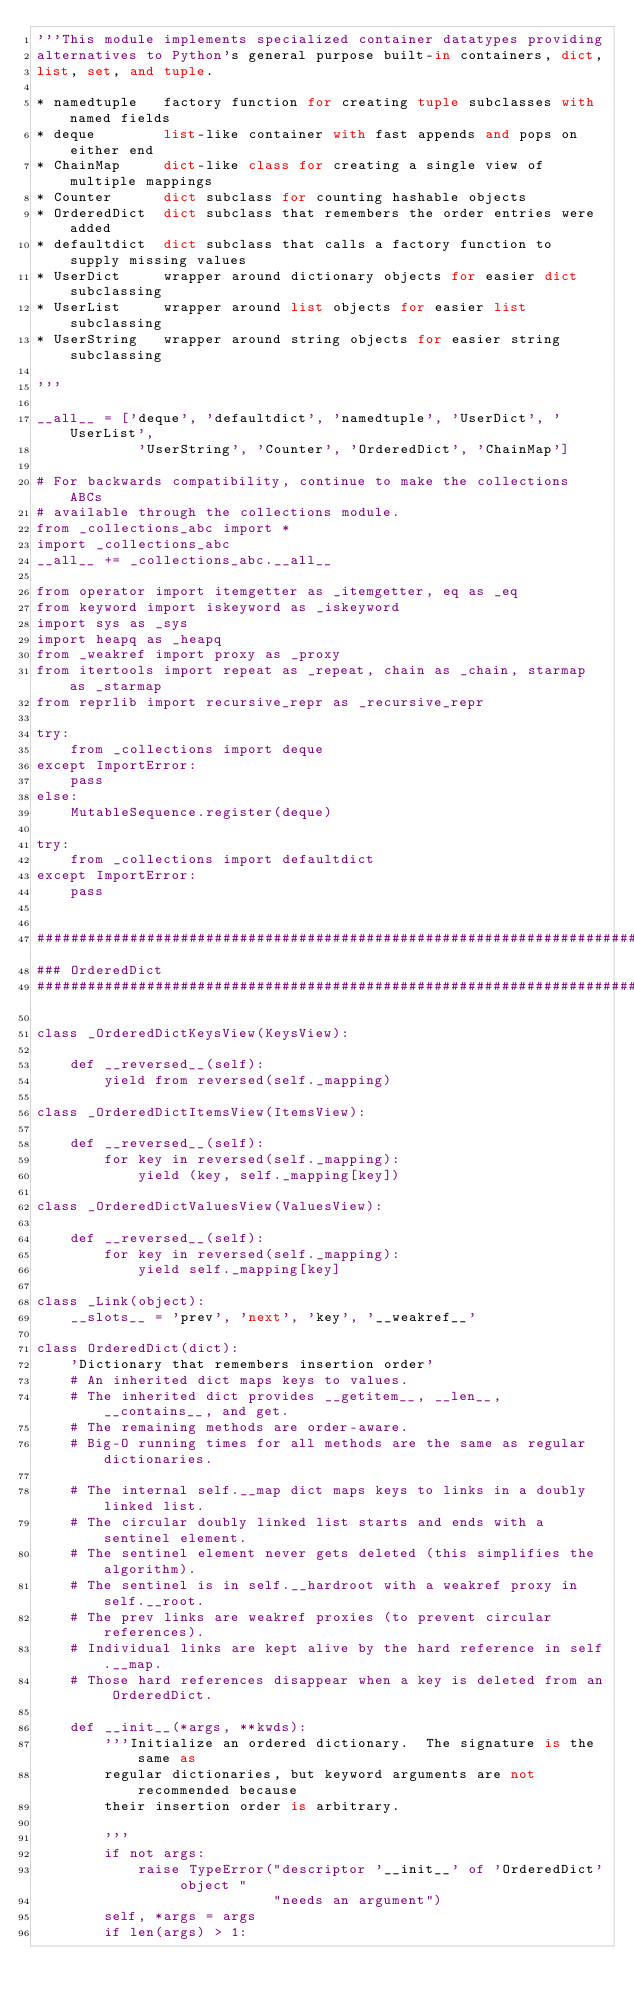<code> <loc_0><loc_0><loc_500><loc_500><_Python_>'''This module implements specialized container datatypes providing
alternatives to Python's general purpose built-in containers, dict,
list, set, and tuple.

* namedtuple   factory function for creating tuple subclasses with named fields
* deque        list-like container with fast appends and pops on either end
* ChainMap     dict-like class for creating a single view of multiple mappings
* Counter      dict subclass for counting hashable objects
* OrderedDict  dict subclass that remembers the order entries were added
* defaultdict  dict subclass that calls a factory function to supply missing values
* UserDict     wrapper around dictionary objects for easier dict subclassing
* UserList     wrapper around list objects for easier list subclassing
* UserString   wrapper around string objects for easier string subclassing

'''

__all__ = ['deque', 'defaultdict', 'namedtuple', 'UserDict', 'UserList',
            'UserString', 'Counter', 'OrderedDict', 'ChainMap']

# For backwards compatibility, continue to make the collections ABCs
# available through the collections module.
from _collections_abc import *
import _collections_abc
__all__ += _collections_abc.__all__

from operator import itemgetter as _itemgetter, eq as _eq
from keyword import iskeyword as _iskeyword
import sys as _sys
import heapq as _heapq
from _weakref import proxy as _proxy
from itertools import repeat as _repeat, chain as _chain, starmap as _starmap
from reprlib import recursive_repr as _recursive_repr

try:
    from _collections import deque
except ImportError:
    pass
else:
    MutableSequence.register(deque)

try:
    from _collections import defaultdict
except ImportError:
    pass


################################################################################
### OrderedDict
################################################################################

class _OrderedDictKeysView(KeysView):

    def __reversed__(self):
        yield from reversed(self._mapping)

class _OrderedDictItemsView(ItemsView):

    def __reversed__(self):
        for key in reversed(self._mapping):
            yield (key, self._mapping[key])

class _OrderedDictValuesView(ValuesView):

    def __reversed__(self):
        for key in reversed(self._mapping):
            yield self._mapping[key]

class _Link(object):
    __slots__ = 'prev', 'next', 'key', '__weakref__'

class OrderedDict(dict):
    'Dictionary that remembers insertion order'
    # An inherited dict maps keys to values.
    # The inherited dict provides __getitem__, __len__, __contains__, and get.
    # The remaining methods are order-aware.
    # Big-O running times for all methods are the same as regular dictionaries.

    # The internal self.__map dict maps keys to links in a doubly linked list.
    # The circular doubly linked list starts and ends with a sentinel element.
    # The sentinel element never gets deleted (this simplifies the algorithm).
    # The sentinel is in self.__hardroot with a weakref proxy in self.__root.
    # The prev links are weakref proxies (to prevent circular references).
    # Individual links are kept alive by the hard reference in self.__map.
    # Those hard references disappear when a key is deleted from an OrderedDict.

    def __init__(*args, **kwds):
        '''Initialize an ordered dictionary.  The signature is the same as
        regular dictionaries, but keyword arguments are not recommended because
        their insertion order is arbitrary.

        '''
        if not args:
            raise TypeError("descriptor '__init__' of 'OrderedDict' object "
                            "needs an argument")
        self, *args = args
        if len(args) > 1:</code> 